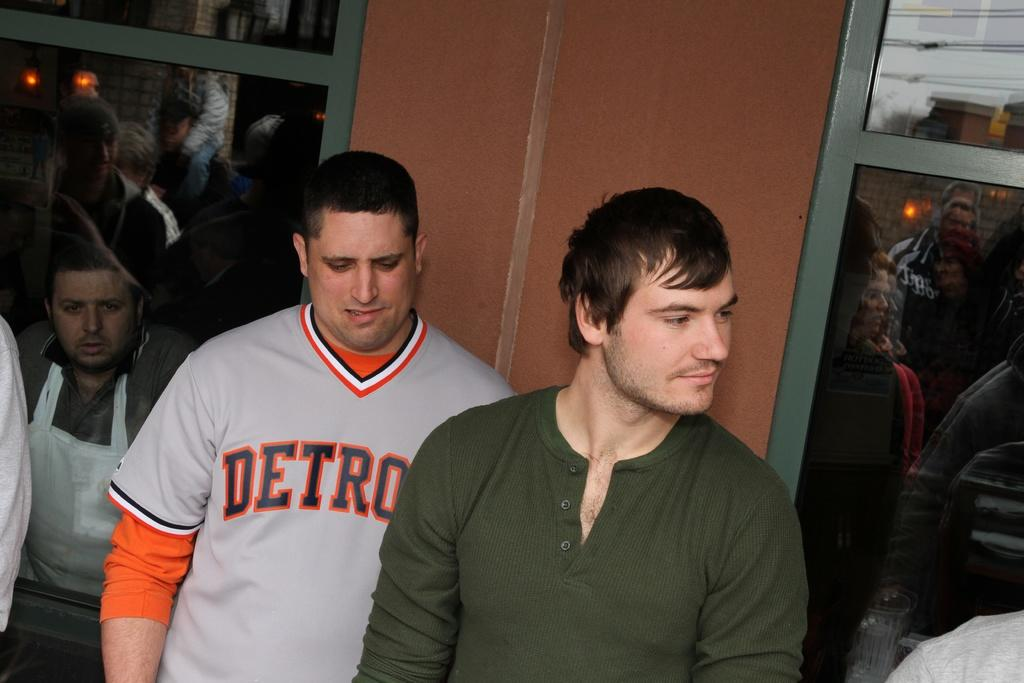Provide a one-sentence caption for the provided image. A man in a Detroit shirt stands behind a man in a green shirt. 